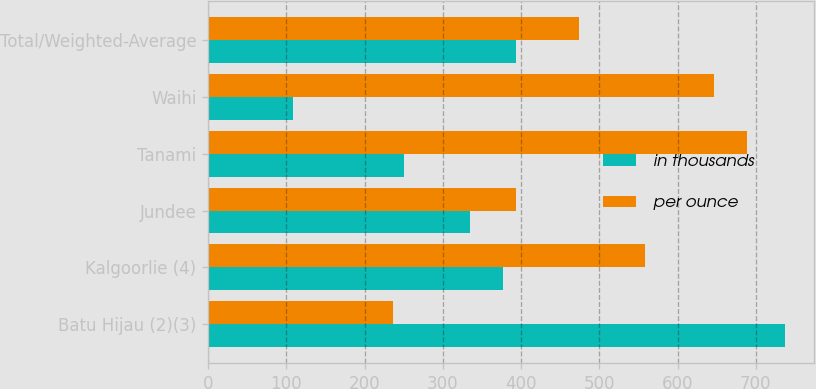<chart> <loc_0><loc_0><loc_500><loc_500><stacked_bar_chart><ecel><fcel>Batu Hijau (2)(3)<fcel>Kalgoorlie (4)<fcel>Jundee<fcel>Tanami<fcel>Waihi<fcel>Total/Weighted-Average<nl><fcel>in thousands<fcel>737<fcel>377<fcel>335<fcel>250<fcel>108<fcel>393<nl><fcel>per ounce<fcel>237<fcel>558<fcel>393<fcel>689<fcel>647<fcel>474<nl></chart> 